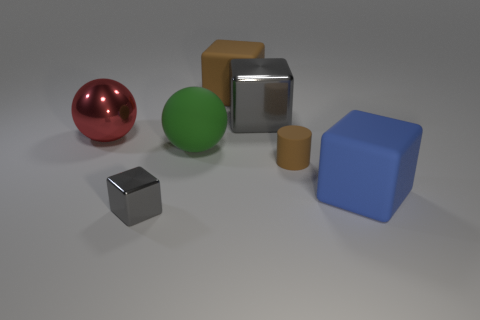Add 1 spheres. How many objects exist? 8 Subtract all spheres. How many objects are left? 5 Add 4 big brown shiny spheres. How many big brown shiny spheres exist? 4 Subtract 0 blue cylinders. How many objects are left? 7 Subtract all metal cubes. Subtract all small gray metallic objects. How many objects are left? 4 Add 4 red metal things. How many red metal things are left? 5 